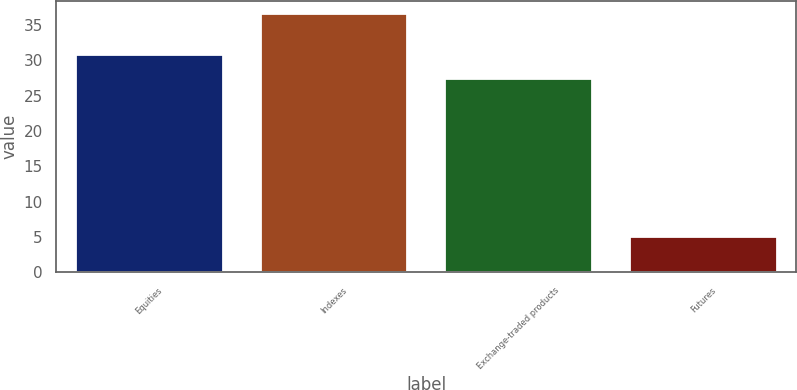<chart> <loc_0><loc_0><loc_500><loc_500><bar_chart><fcel>Equities<fcel>Indexes<fcel>Exchange-traded products<fcel>Futures<nl><fcel>30.8<fcel>36.6<fcel>27.5<fcel>5.1<nl></chart> 